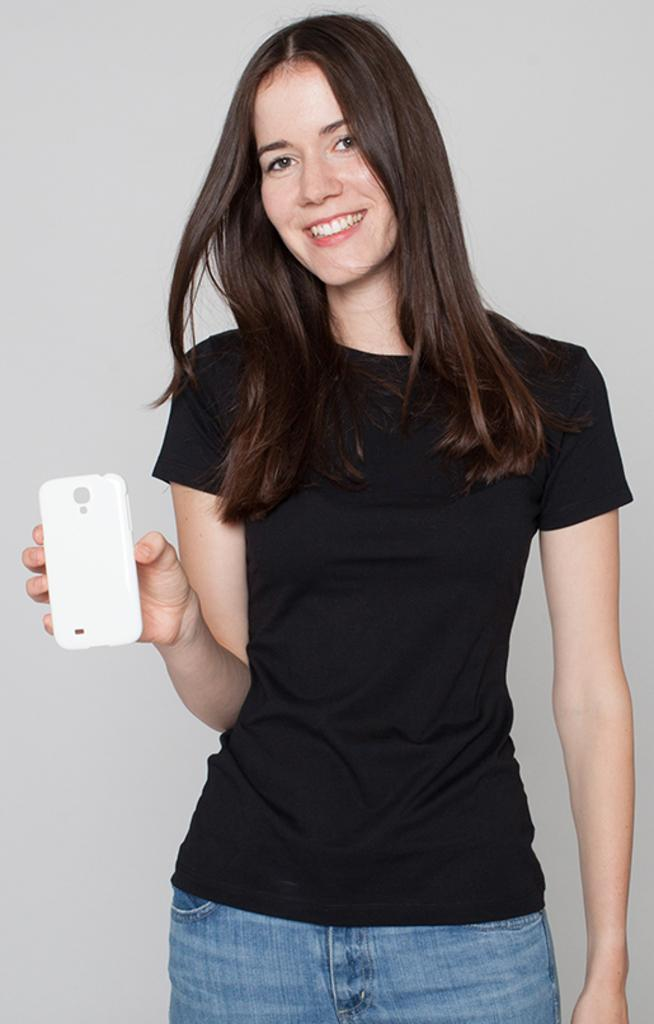Where was the image taken? The image is taken indoors. Who is in the image? There is a woman in the image. What is the woman wearing? The woman is wearing a black shirt and blue jeans. What is the woman holding in her hand? The woman is holding a phone case in her hand. What expression does the woman have? The woman is smiling. What type of root can be seen growing from the woman's hair in the image? There is no root growing from the woman's hair in the image. How many grandfathers are visible in the image? There are no grandfathers present in the image; it features a woman. 